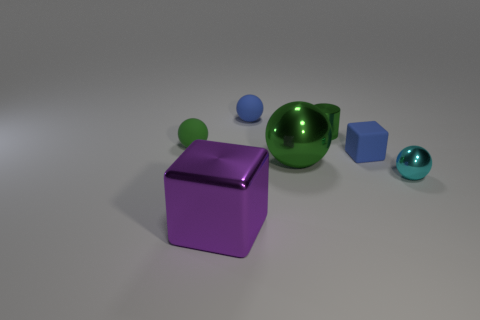Do the object that is in front of the cyan object and the green ball right of the large purple object have the same size?
Provide a short and direct response. Yes. There is a small green metallic object; what shape is it?
Ensure brevity in your answer.  Cylinder. There is a metal sphere that is the same color as the shiny cylinder; what is its size?
Your answer should be very brief. Large. There is a big ball that is the same material as the tiny green cylinder; what color is it?
Give a very brief answer. Green. Is the tiny green ball made of the same material as the tiny green cylinder behind the metal cube?
Keep it short and to the point. No. The cylinder has what color?
Your answer should be compact. Green. What size is the green ball that is made of the same material as the big purple block?
Ensure brevity in your answer.  Large. There is a big metallic thing behind the small sphere that is on the right side of the big green shiny thing; what number of tiny blue rubber things are left of it?
Offer a very short reply. 1. Do the small block and the tiny matte ball that is behind the green matte thing have the same color?
Ensure brevity in your answer.  Yes. There is a big object that is the same color as the cylinder; what is its shape?
Ensure brevity in your answer.  Sphere. 